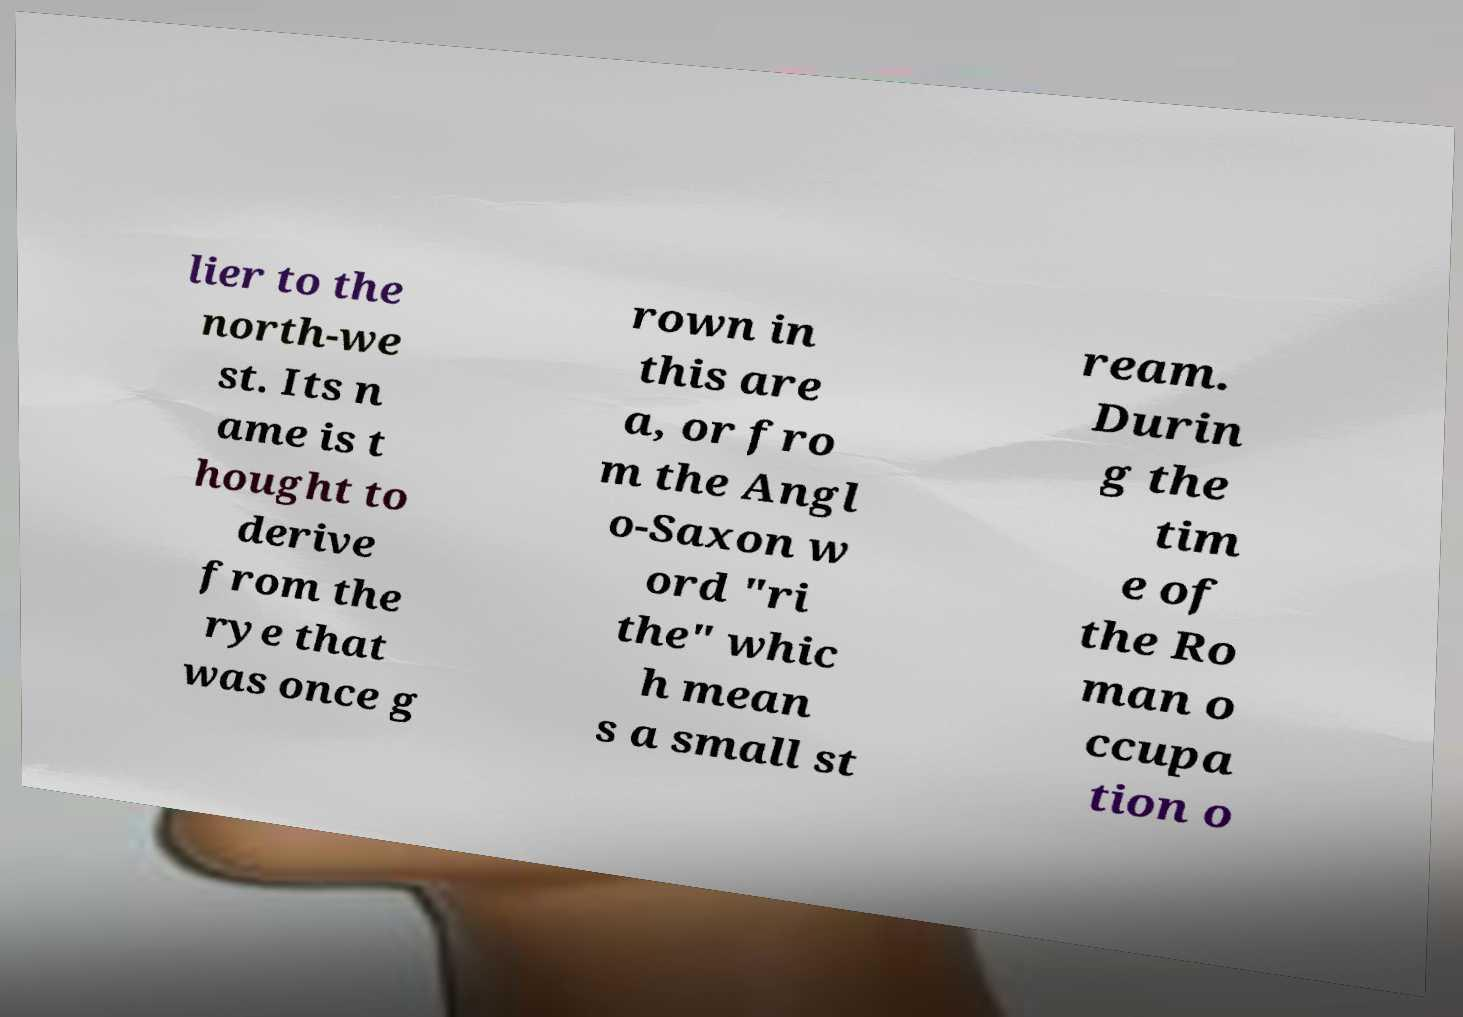For documentation purposes, I need the text within this image transcribed. Could you provide that? lier to the north-we st. Its n ame is t hought to derive from the rye that was once g rown in this are a, or fro m the Angl o-Saxon w ord "ri the" whic h mean s a small st ream. Durin g the tim e of the Ro man o ccupa tion o 